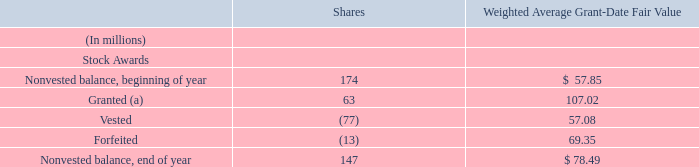During fiscal year 2019, the following activity occurred under our stock plans:
(a) Includes 2 million, 3 million, and 2 million of PSUs granted at target and performance adjustments above target levels for fiscal years 2019, 2018, and 2017, respectively.
As of June 30, 2019, there was approximately $8.6 billion of total unrecognized compensation costs related to stock awards. These costs are expected to be recognized over a weighted average period of 3 years. The weighted average grant-date fair value of stock awards granted was $107.02, $75.88, and $55.64 for fiscal years 2019, 2018, and 2017, respectively. The fair value of stock awards vested was $8.7 billion, $6.6 billion, and $4.8 billion, for fiscal years 2019, 2018, and 2017, respectively.
How much were the total unrecognized compensation costs related to stock awards as of June 30, 2019? As of june 30, 2019, there was approximately $8.6 billion of total unrecognized compensation costs related to stock awards. What did the granted stock awards include? (a) includes 2 million, 3 million, and 2 million of psus granted at target and performance adjustments above target levels for fiscal years 2019, 2018, and 2017, respectively. What was the fair value of stock awards vested for 2017? The fair value of stock awards vested was $8.7 billion, $6.6 billion, and $4.8 billion, for fiscal years 2019, 2018, and 2017, respectively. How many items affect the nonvested balance? Granted##vested##forfeited
Answer: 3. What was the number of stock awards that were granted in 2019, not including the PSUs granted?
Answer scale should be: million. 63-2 
Answer: 61. What was the average fair value of stock awards vested over the 3 year period from 2017 to 2019?
Answer scale should be: billion. (8.7+6.6+4.8)/3
Answer: 6.7. 